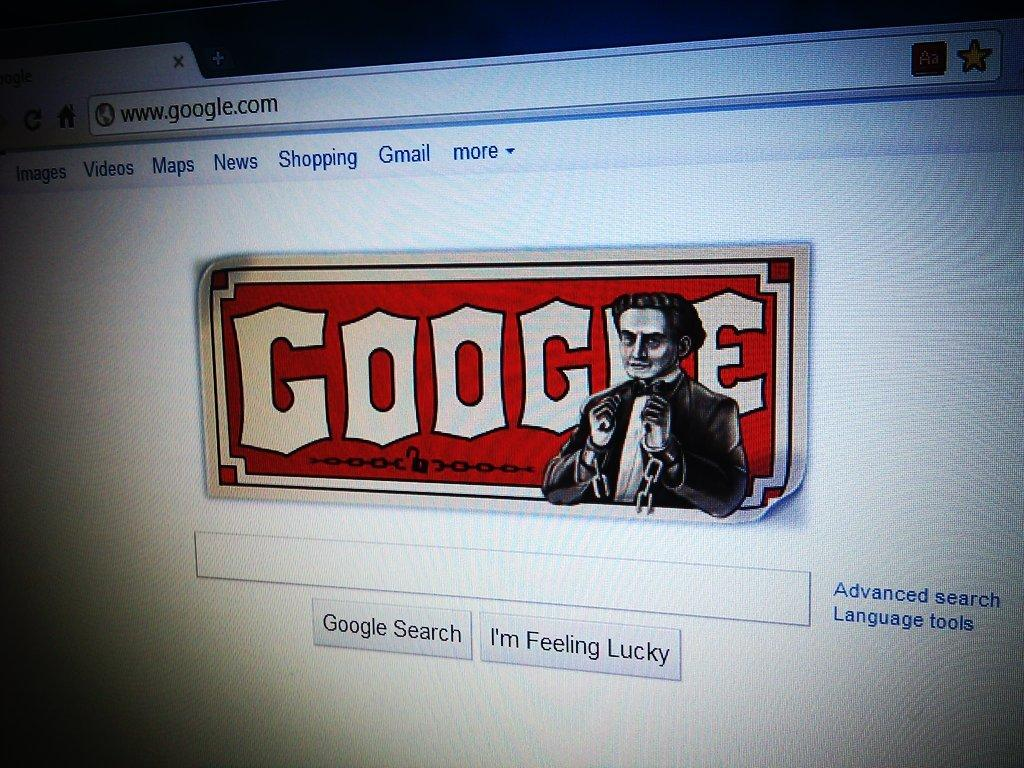<image>
Write a terse but informative summary of the picture. Google home page screen on a computer with a design of a man in chains. 